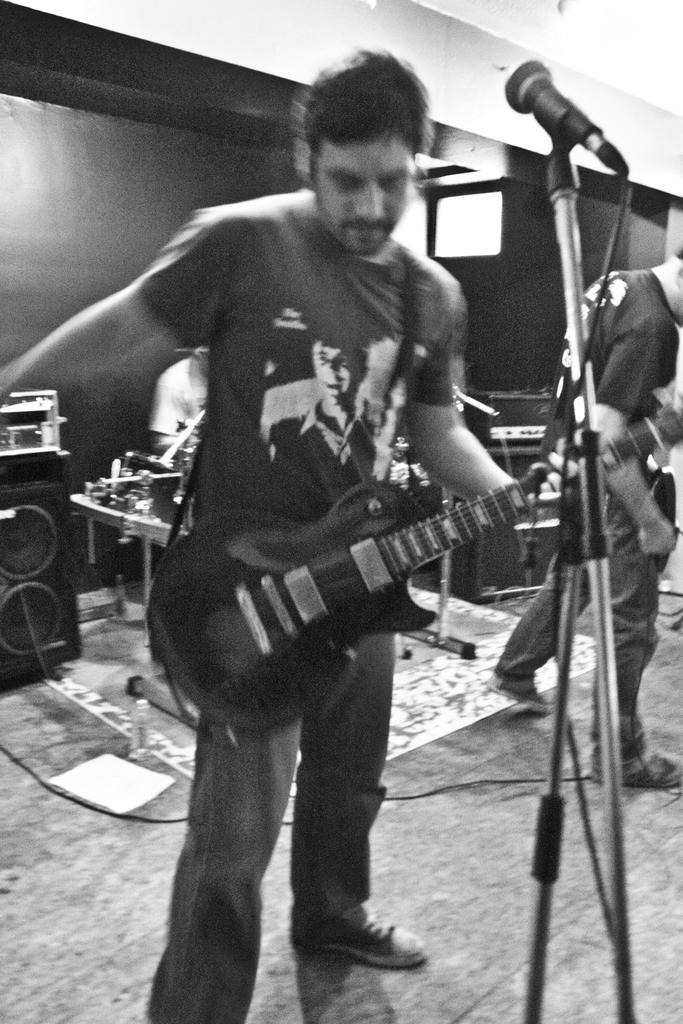Who is the main subject in the image? There is a man in the image. What is the man doing in the image? The man is standing and holding a guitar. What other objects can be seen in the image? There is a microphone and a speaker in the background of the image. Are there any other people in the image? Yes, there are two people in the background of the image. What type of rod is the man using to play the guitar in the image? There is no rod present in the image; the man is playing the guitar with his hands. Is there a pet visible in the image? No, there is no pet present in the image. 